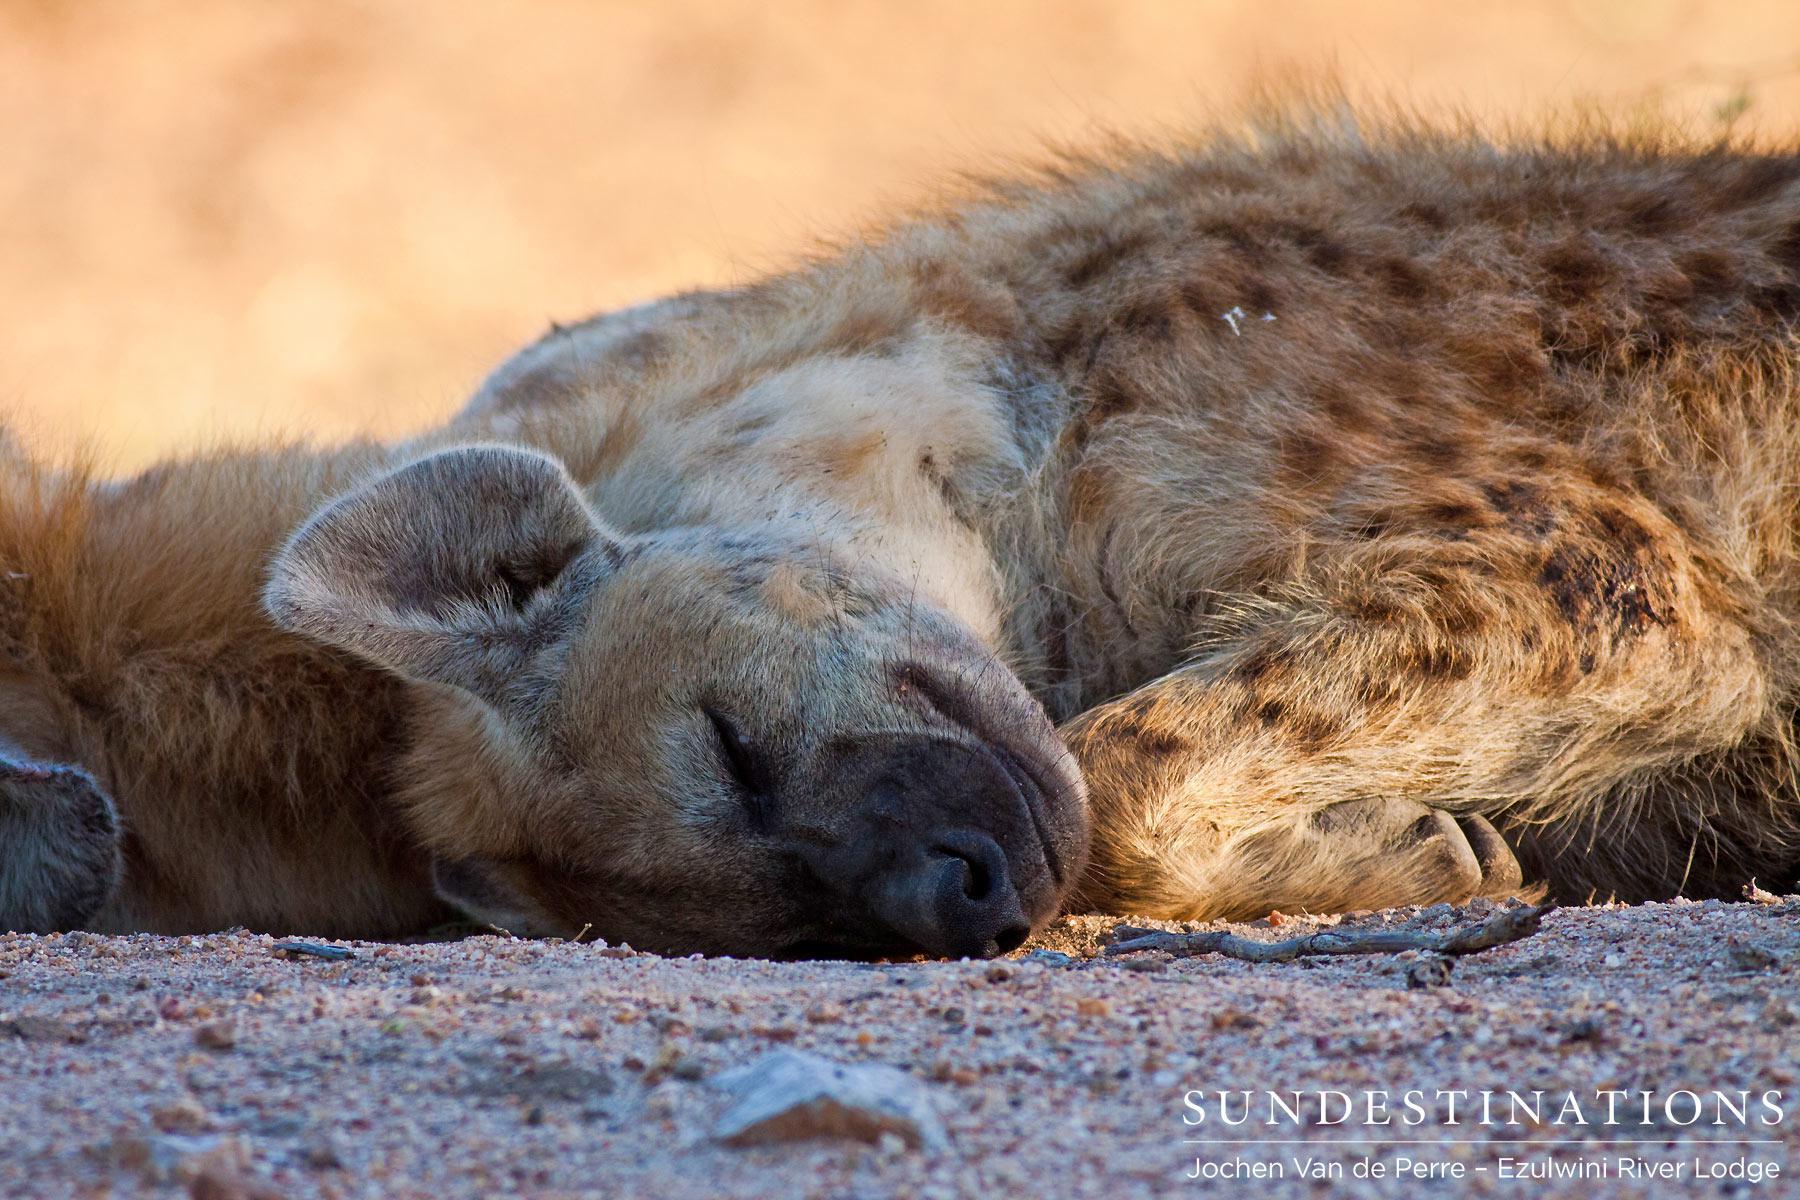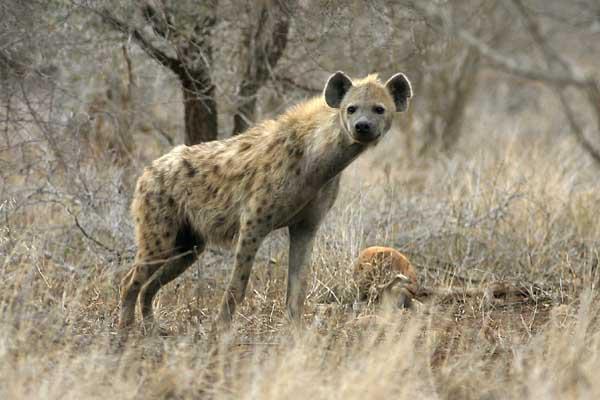The first image is the image on the left, the second image is the image on the right. Considering the images on both sides, is "The left image shows a hyena standing with its body turned leftward, and the right image includes a hyena with opened mouth showing teeth." valid? Answer yes or no. No. The first image is the image on the left, the second image is the image on the right. Analyze the images presented: Is the assertion "A hyena is standing in a field in the image on the left." valid? Answer yes or no. No. 